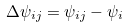<formula> <loc_0><loc_0><loc_500><loc_500>\Delta \psi _ { i j } = \psi _ { i j } - \psi _ { i }</formula> 